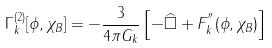<formula> <loc_0><loc_0><loc_500><loc_500>\Gamma _ { k } ^ { ( 2 ) } [ \phi , \chi _ { B } ] = - \frac { 3 } { 4 \pi G _ { k } } \left [ - \widehat { \square } + F ^ { ^ { \prime \prime } } _ { k } ( \phi , \chi _ { B } ) \right ]</formula> 